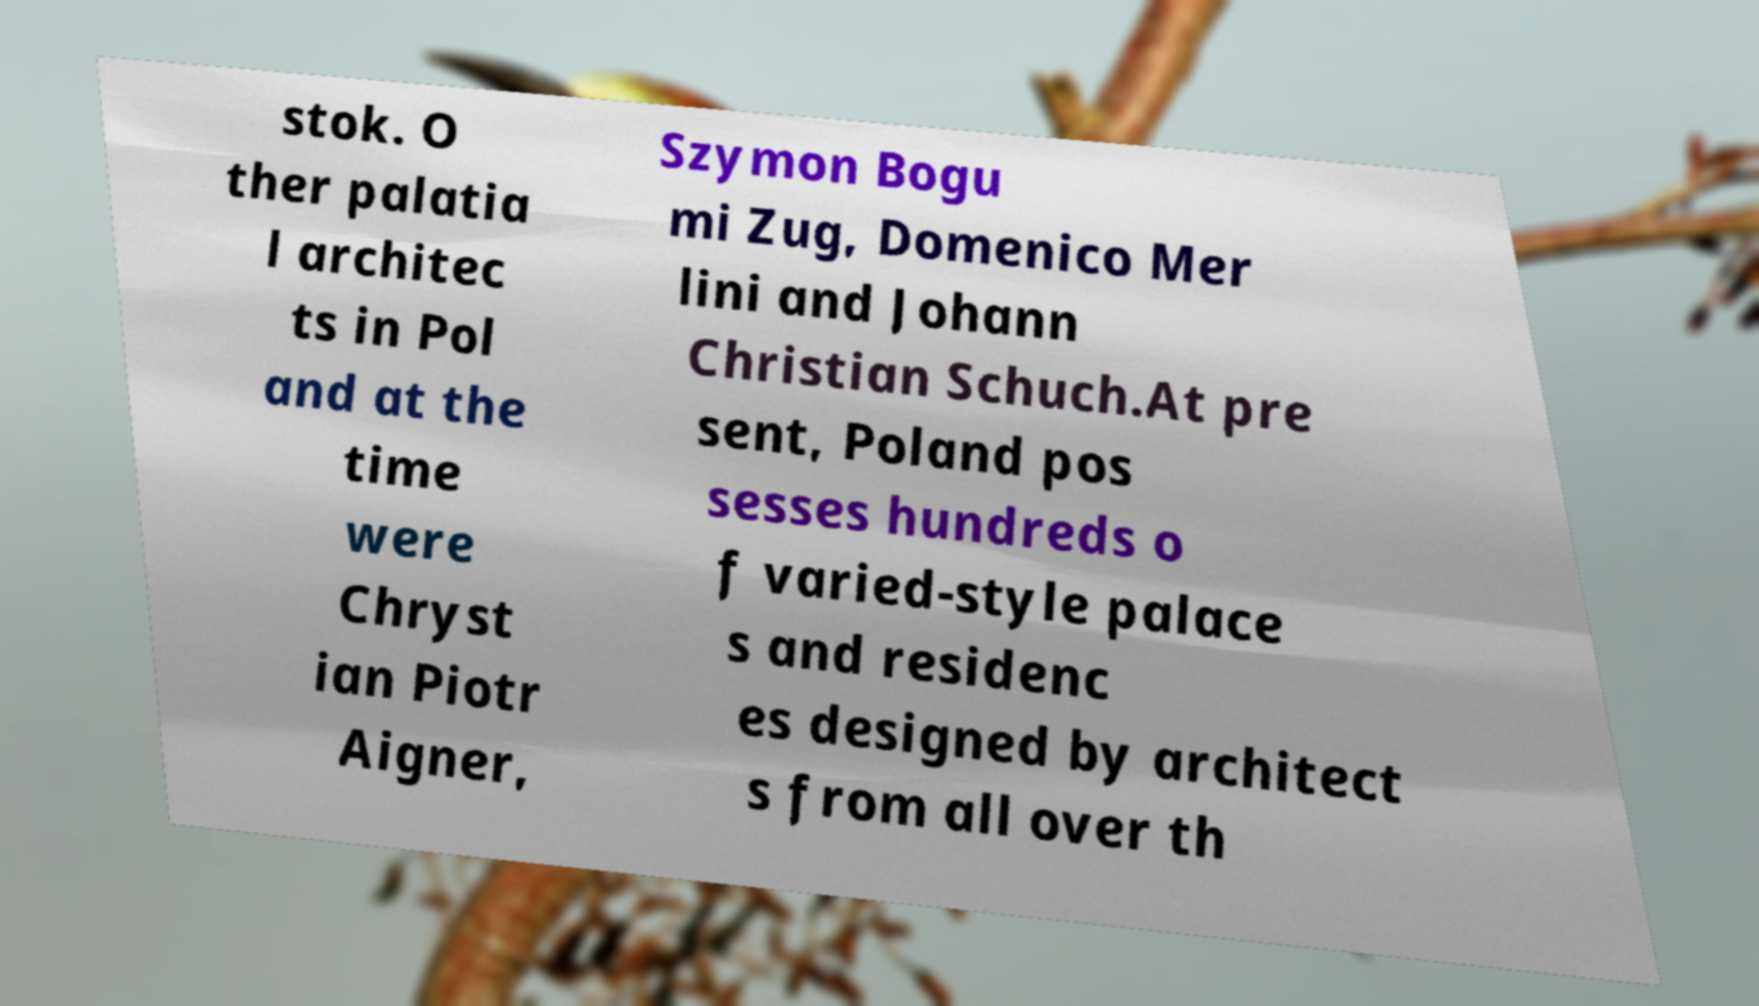I need the written content from this picture converted into text. Can you do that? stok. O ther palatia l architec ts in Pol and at the time were Chryst ian Piotr Aigner, Szymon Bogu mi Zug, Domenico Mer lini and Johann Christian Schuch.At pre sent, Poland pos sesses hundreds o f varied-style palace s and residenc es designed by architect s from all over th 